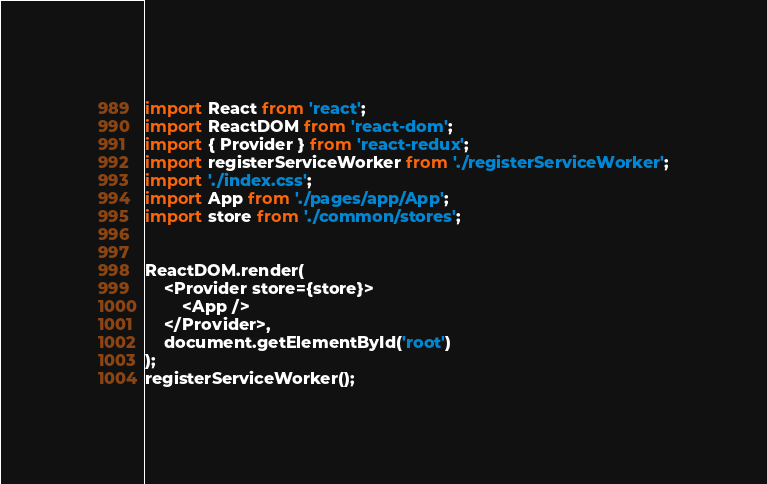<code> <loc_0><loc_0><loc_500><loc_500><_JavaScript_>import React from 'react';
import ReactDOM from 'react-dom';
import { Provider } from 'react-redux';
import registerServiceWorker from './registerServiceWorker';
import './index.css';
import App from './pages/app/App';
import store from './common/stores';


ReactDOM.render(
    <Provider store={store}>
        <App />
    </Provider>, 
    document.getElementById('root')
);
registerServiceWorker();
</code> 